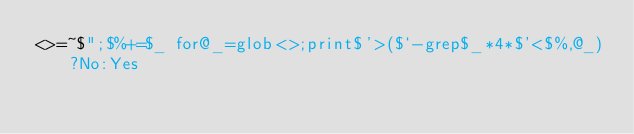<code> <loc_0><loc_0><loc_500><loc_500><_Perl_><>=~$";$%+=$_ for@_=glob<>;print$'>($`-grep$_*4*$'<$%,@_)?No:Yes</code> 